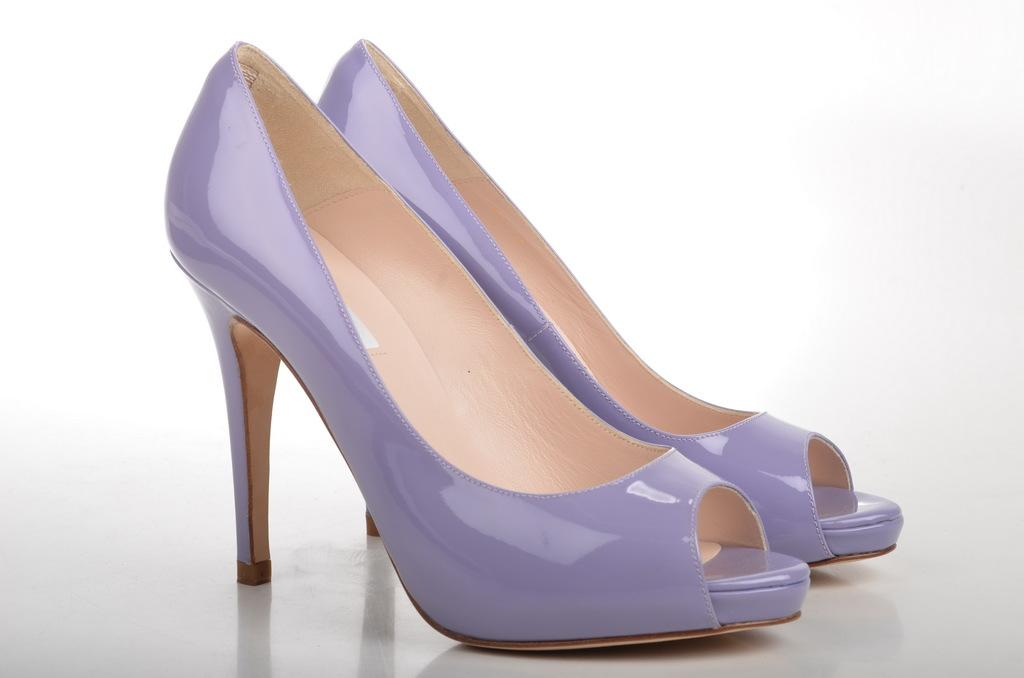What type of footwear is present in the image? There is a pair of high heels in the image. What color are the high heels? The high heels are purple in color. Where are the high heels located in the image? The high heels are placed on the floor. What type of wall can be seen in the image? There is no wall present in the image; it only features a pair of purple high heels placed on the floor. 